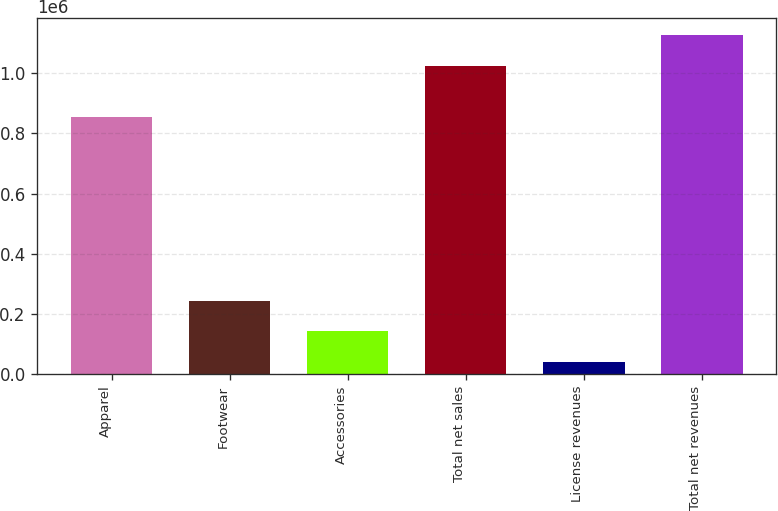Convert chart. <chart><loc_0><loc_0><loc_500><loc_500><bar_chart><fcel>Apparel<fcel>Footwear<fcel>Accessories<fcel>Total net sales<fcel>License revenues<fcel>Total net revenues<nl><fcel>853493<fcel>244287<fcel>141832<fcel>1.02455e+06<fcel>39377<fcel>1.127e+06<nl></chart> 